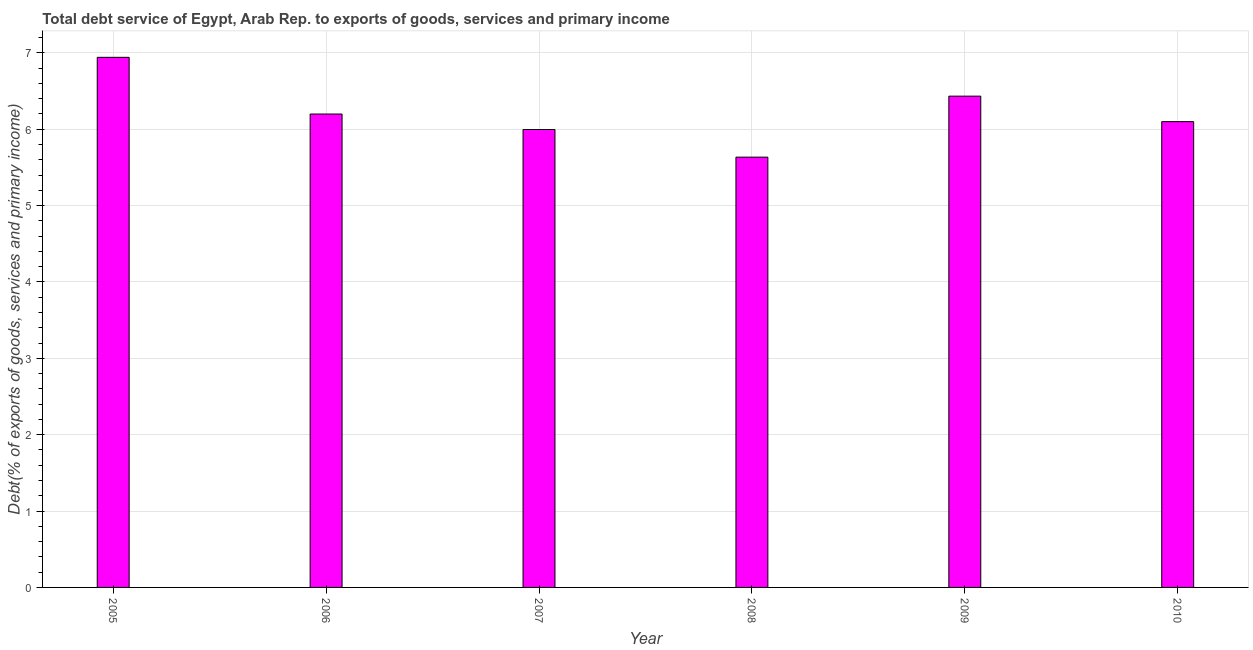Does the graph contain grids?
Offer a very short reply. Yes. What is the title of the graph?
Your answer should be very brief. Total debt service of Egypt, Arab Rep. to exports of goods, services and primary income. What is the label or title of the Y-axis?
Keep it short and to the point. Debt(% of exports of goods, services and primary income). What is the total debt service in 2009?
Your answer should be compact. 6.43. Across all years, what is the maximum total debt service?
Give a very brief answer. 6.94. Across all years, what is the minimum total debt service?
Your response must be concise. 5.63. In which year was the total debt service maximum?
Ensure brevity in your answer.  2005. What is the sum of the total debt service?
Your response must be concise. 37.31. What is the difference between the total debt service in 2007 and 2008?
Your answer should be compact. 0.36. What is the average total debt service per year?
Make the answer very short. 6.22. What is the median total debt service?
Your response must be concise. 6.15. Do a majority of the years between 2006 and 2010 (inclusive) have total debt service greater than 2.2 %?
Keep it short and to the point. Yes. What is the ratio of the total debt service in 2005 to that in 2007?
Ensure brevity in your answer.  1.16. Is the difference between the total debt service in 2006 and 2007 greater than the difference between any two years?
Your answer should be very brief. No. What is the difference between the highest and the second highest total debt service?
Provide a short and direct response. 0.51. Is the sum of the total debt service in 2007 and 2008 greater than the maximum total debt service across all years?
Your answer should be compact. Yes. What is the difference between the highest and the lowest total debt service?
Your answer should be compact. 1.31. In how many years, is the total debt service greater than the average total debt service taken over all years?
Make the answer very short. 2. Are all the bars in the graph horizontal?
Your answer should be compact. No. What is the difference between two consecutive major ticks on the Y-axis?
Keep it short and to the point. 1. Are the values on the major ticks of Y-axis written in scientific E-notation?
Offer a very short reply. No. What is the Debt(% of exports of goods, services and primary income) of 2005?
Your response must be concise. 6.94. What is the Debt(% of exports of goods, services and primary income) of 2006?
Your answer should be very brief. 6.2. What is the Debt(% of exports of goods, services and primary income) in 2007?
Ensure brevity in your answer.  6. What is the Debt(% of exports of goods, services and primary income) of 2008?
Your answer should be compact. 5.63. What is the Debt(% of exports of goods, services and primary income) of 2009?
Provide a short and direct response. 6.43. What is the Debt(% of exports of goods, services and primary income) in 2010?
Offer a terse response. 6.1. What is the difference between the Debt(% of exports of goods, services and primary income) in 2005 and 2006?
Ensure brevity in your answer.  0.74. What is the difference between the Debt(% of exports of goods, services and primary income) in 2005 and 2007?
Ensure brevity in your answer.  0.95. What is the difference between the Debt(% of exports of goods, services and primary income) in 2005 and 2008?
Give a very brief answer. 1.31. What is the difference between the Debt(% of exports of goods, services and primary income) in 2005 and 2009?
Offer a terse response. 0.51. What is the difference between the Debt(% of exports of goods, services and primary income) in 2005 and 2010?
Your answer should be compact. 0.84. What is the difference between the Debt(% of exports of goods, services and primary income) in 2006 and 2007?
Offer a very short reply. 0.2. What is the difference between the Debt(% of exports of goods, services and primary income) in 2006 and 2008?
Make the answer very short. 0.56. What is the difference between the Debt(% of exports of goods, services and primary income) in 2006 and 2009?
Provide a succinct answer. -0.23. What is the difference between the Debt(% of exports of goods, services and primary income) in 2006 and 2010?
Your answer should be compact. 0.1. What is the difference between the Debt(% of exports of goods, services and primary income) in 2007 and 2008?
Your response must be concise. 0.36. What is the difference between the Debt(% of exports of goods, services and primary income) in 2007 and 2009?
Your response must be concise. -0.44. What is the difference between the Debt(% of exports of goods, services and primary income) in 2007 and 2010?
Provide a short and direct response. -0.1. What is the difference between the Debt(% of exports of goods, services and primary income) in 2008 and 2009?
Provide a short and direct response. -0.8. What is the difference between the Debt(% of exports of goods, services and primary income) in 2008 and 2010?
Offer a very short reply. -0.47. What is the difference between the Debt(% of exports of goods, services and primary income) in 2009 and 2010?
Your response must be concise. 0.33. What is the ratio of the Debt(% of exports of goods, services and primary income) in 2005 to that in 2006?
Your response must be concise. 1.12. What is the ratio of the Debt(% of exports of goods, services and primary income) in 2005 to that in 2007?
Provide a succinct answer. 1.16. What is the ratio of the Debt(% of exports of goods, services and primary income) in 2005 to that in 2008?
Keep it short and to the point. 1.23. What is the ratio of the Debt(% of exports of goods, services and primary income) in 2005 to that in 2009?
Provide a short and direct response. 1.08. What is the ratio of the Debt(% of exports of goods, services and primary income) in 2005 to that in 2010?
Your response must be concise. 1.14. What is the ratio of the Debt(% of exports of goods, services and primary income) in 2006 to that in 2007?
Your answer should be compact. 1.03. What is the ratio of the Debt(% of exports of goods, services and primary income) in 2006 to that in 2009?
Your answer should be very brief. 0.96. What is the ratio of the Debt(% of exports of goods, services and primary income) in 2007 to that in 2008?
Your answer should be compact. 1.06. What is the ratio of the Debt(% of exports of goods, services and primary income) in 2007 to that in 2009?
Give a very brief answer. 0.93. What is the ratio of the Debt(% of exports of goods, services and primary income) in 2008 to that in 2009?
Provide a succinct answer. 0.88. What is the ratio of the Debt(% of exports of goods, services and primary income) in 2008 to that in 2010?
Keep it short and to the point. 0.92. What is the ratio of the Debt(% of exports of goods, services and primary income) in 2009 to that in 2010?
Your answer should be compact. 1.05. 